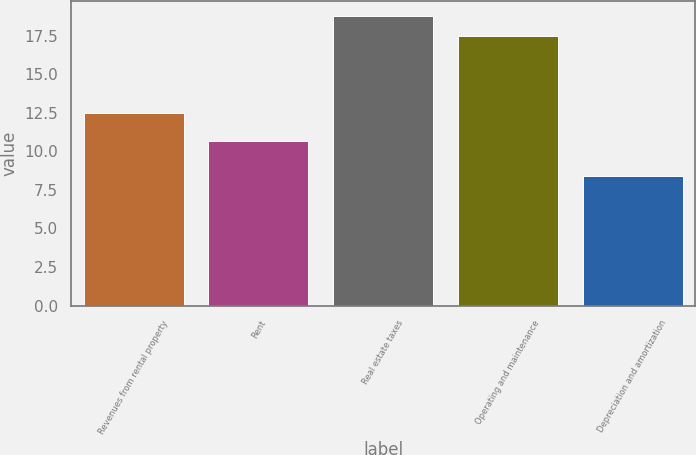Convert chart. <chart><loc_0><loc_0><loc_500><loc_500><bar_chart><fcel>Revenues from rental property<fcel>Rent<fcel>Real estate taxes<fcel>Operating and maintenance<fcel>Depreciation and amortization<nl><fcel>12.5<fcel>10.7<fcel>18.8<fcel>17.5<fcel>8.4<nl></chart> 